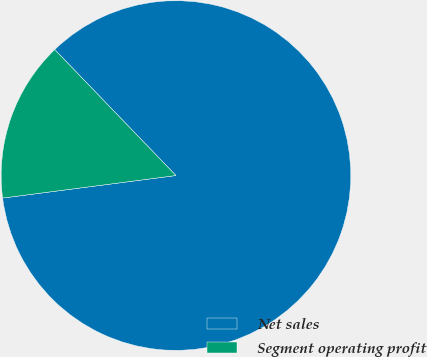<chart> <loc_0><loc_0><loc_500><loc_500><pie_chart><fcel>Net sales<fcel>Segment operating profit<nl><fcel>85.14%<fcel>14.86%<nl></chart> 